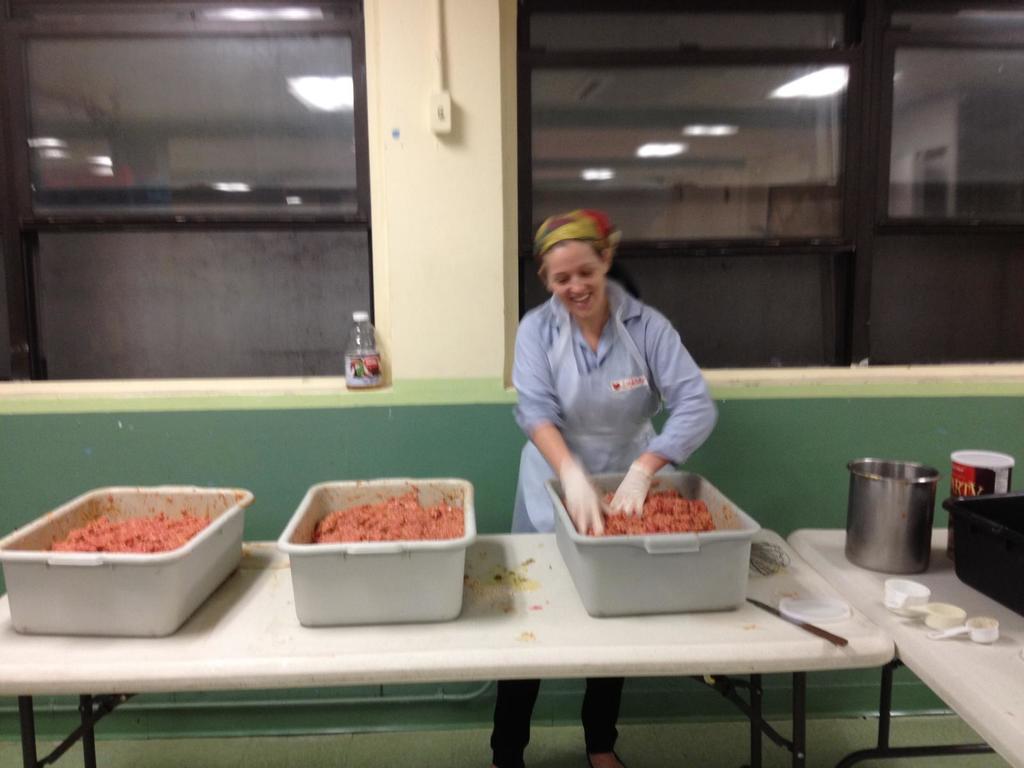Describe this image in one or two sentences. There is a woman standing in the center and she is smiling. She is mixing something in this tub with her hands. 